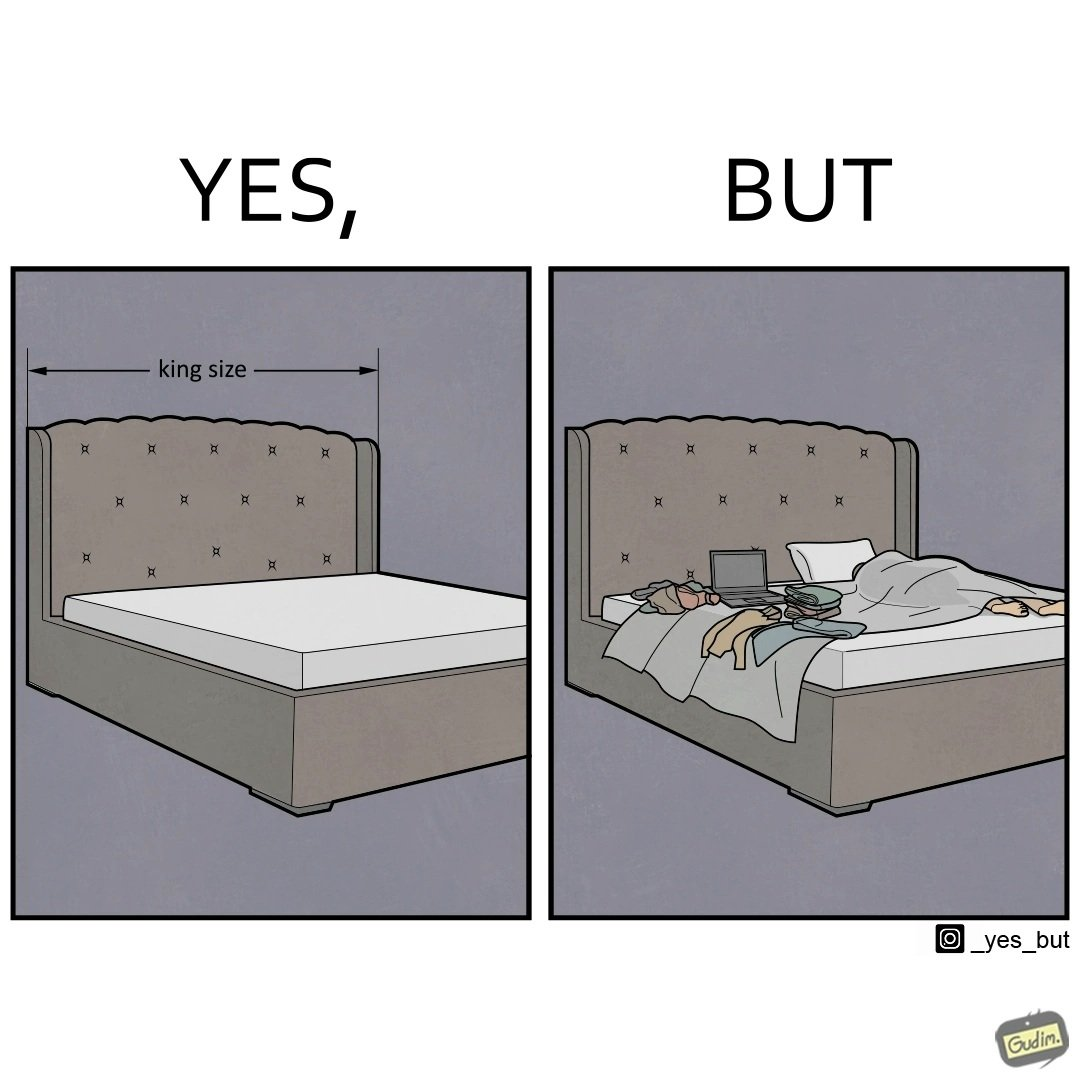Is this image satirical or non-satirical? Yes, this image is satirical. 